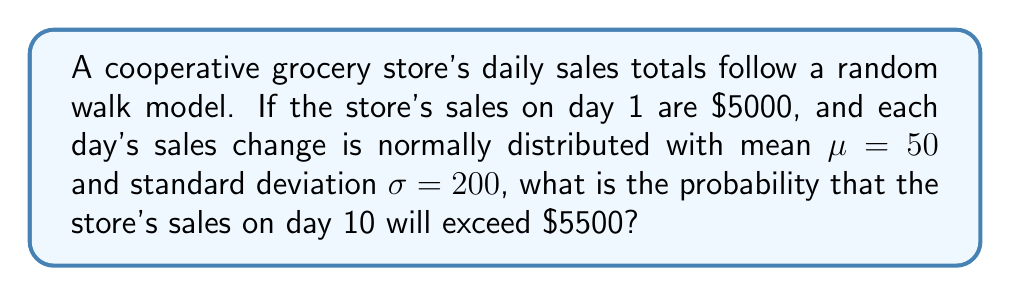What is the answer to this math problem? Let's approach this step-by-step:

1) In a random walk model, the change in sales from one day to the next is independent and identically distributed. Here, it follows a normal distribution with $\mu = 50$ and $\sigma = 200$.

2) Over 9 days (from day 1 to day 10), the total change in sales will also be normally distributed. The mean and variance of this distribution can be calculated as follows:

   Mean: $9 \times \mu = 9 \times 50 = 450$
   Variance: $9 \times \sigma^2 = 9 \times 200^2 = 360,000$

3) Therefore, the sales on day 10 will be normally distributed with:
   Mean: $5000 + 450 = 5450$
   Standard deviation: $\sqrt{360,000} = 600$

4) We want to find $P(X > 5500)$ where $X$ is the sales on day 10.

5) We can standardize this to a standard normal distribution:

   $$Z = \frac{X - \mu}{\sigma} = \frac{5500 - 5450}{600} = \frac{50}{600} \approx 0.0833$$

6) We need to find $P(Z > 0.0833)$. Using a standard normal table or calculator:

   $P(Z > 0.0833) = 1 - P(Z < 0.0833) \approx 1 - 0.5332 \approx 0.4668$

Therefore, the probability that the store's sales on day 10 will exceed $5500 is approximately 0.4668 or 46.68%.
Answer: 0.4668 